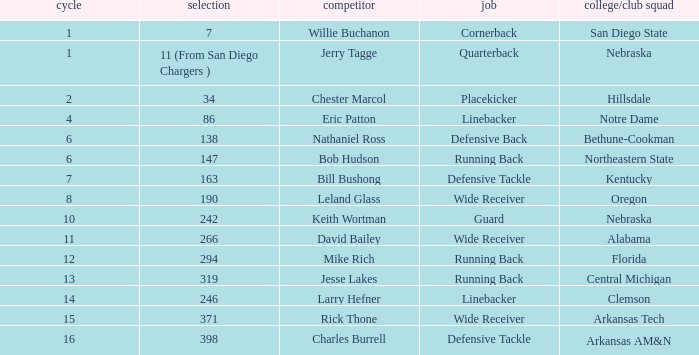Which pick has a school/club team that is kentucky? 163.0. 